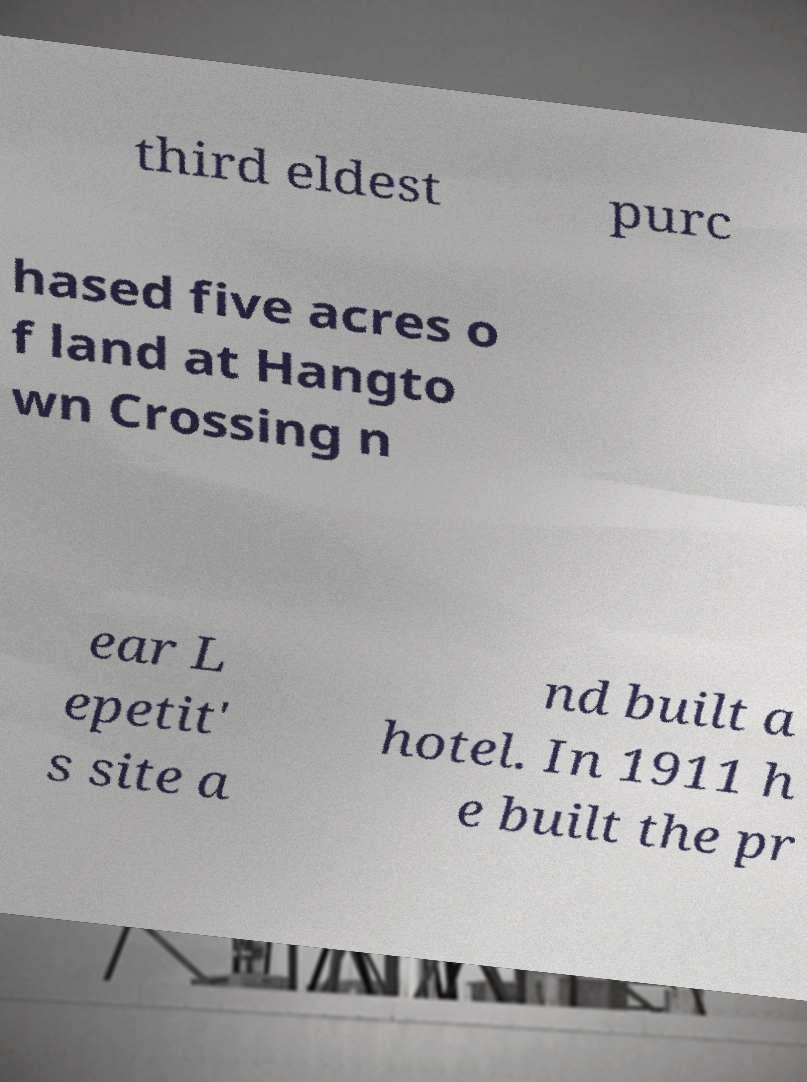Please identify and transcribe the text found in this image. third eldest purc hased five acres o f land at Hangto wn Crossing n ear L epetit' s site a nd built a hotel. In 1911 h e built the pr 